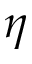Convert formula to latex. <formula><loc_0><loc_0><loc_500><loc_500>\eta</formula> 